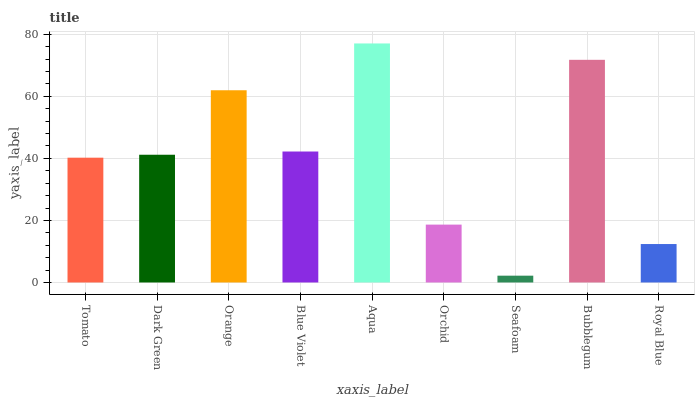Is Seafoam the minimum?
Answer yes or no. Yes. Is Aqua the maximum?
Answer yes or no. Yes. Is Dark Green the minimum?
Answer yes or no. No. Is Dark Green the maximum?
Answer yes or no. No. Is Dark Green greater than Tomato?
Answer yes or no. Yes. Is Tomato less than Dark Green?
Answer yes or no. Yes. Is Tomato greater than Dark Green?
Answer yes or no. No. Is Dark Green less than Tomato?
Answer yes or no. No. Is Dark Green the high median?
Answer yes or no. Yes. Is Dark Green the low median?
Answer yes or no. Yes. Is Orange the high median?
Answer yes or no. No. Is Bubblegum the low median?
Answer yes or no. No. 